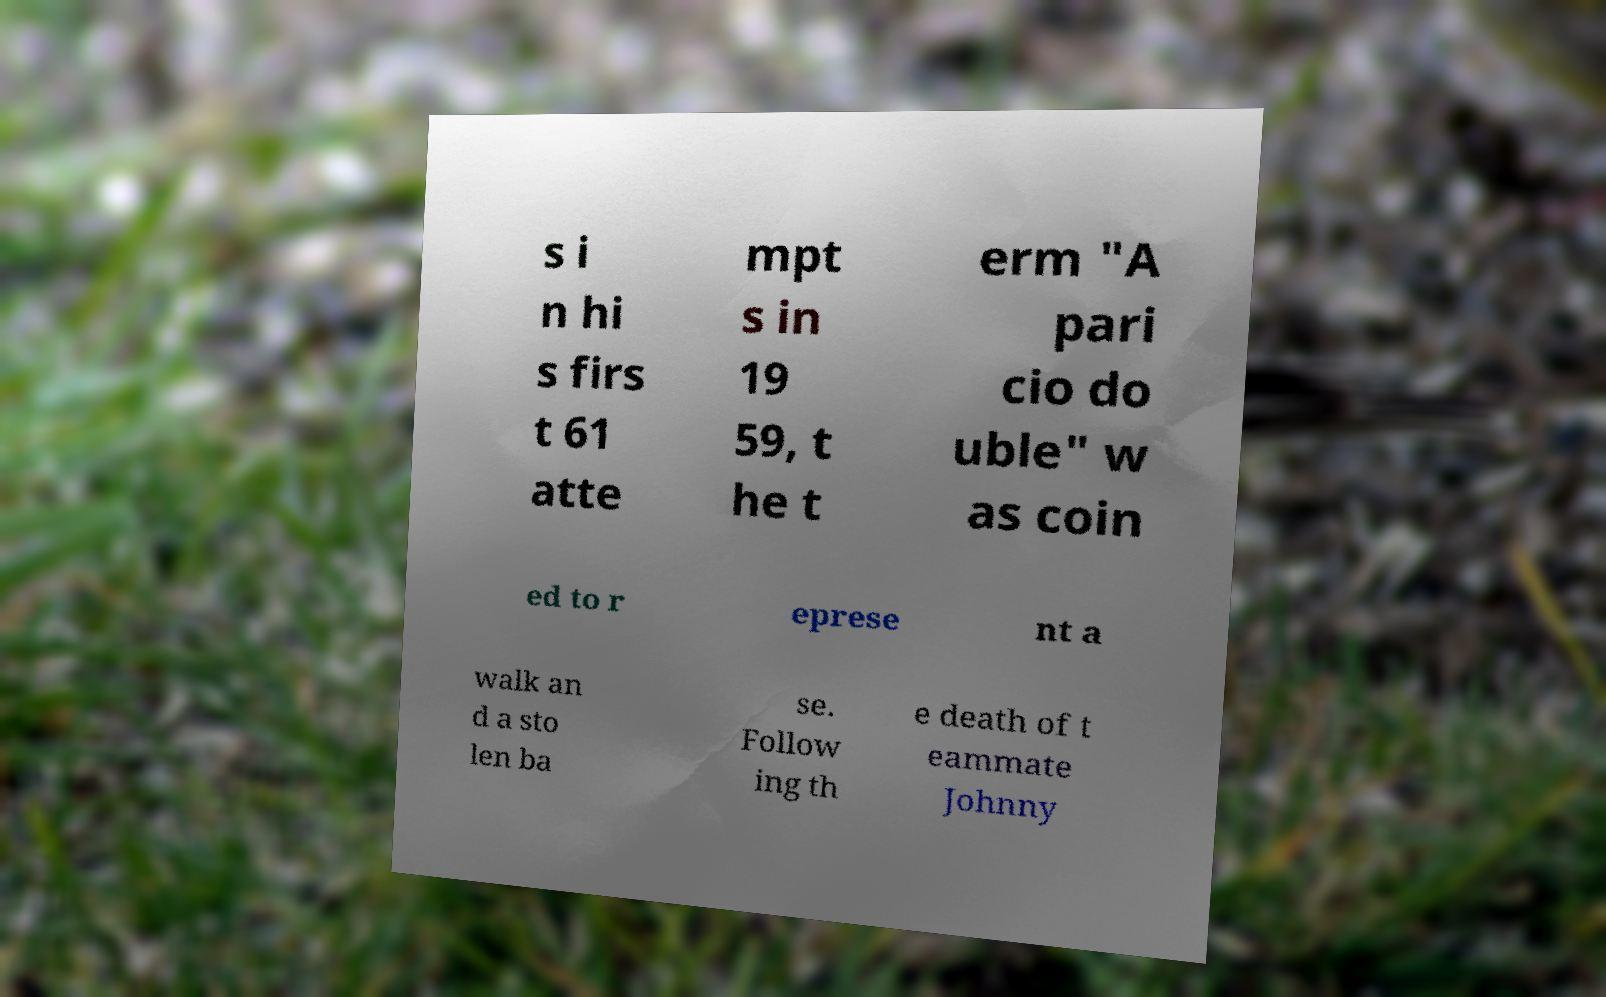I need the written content from this picture converted into text. Can you do that? s i n hi s firs t 61 atte mpt s in 19 59, t he t erm "A pari cio do uble" w as coin ed to r eprese nt a walk an d a sto len ba se. Follow ing th e death of t eammate Johnny 